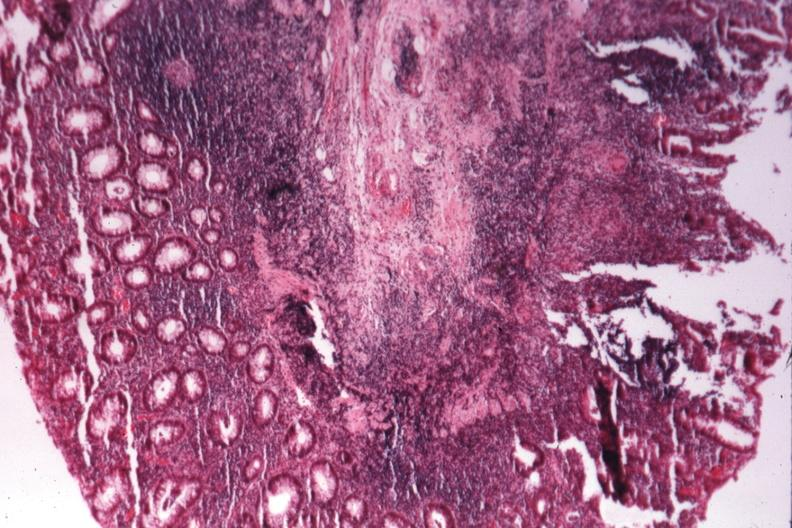s placenta present?
Answer the question using a single word or phrase. No 